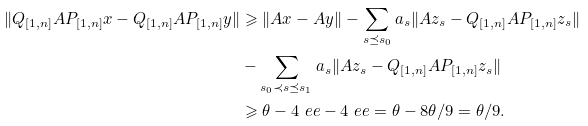<formula> <loc_0><loc_0><loc_500><loc_500>\| Q _ { [ 1 , n ] } A P _ { [ 1 , n ] } x - Q _ { [ 1 , n ] } A P _ { [ 1 , n ] } y \| & \geqslant \| A x - A y \| - \sum _ { s \preceq s _ { 0 } } a _ { s } \| A z _ { s } - Q _ { [ 1 , n ] } A P _ { [ 1 , n ] } z _ { s } \| \\ & - \sum _ { s _ { 0 } \prec s \preceq s _ { 1 } } a _ { s } \| A z _ { s } - Q _ { [ 1 , n ] } A P _ { [ 1 , n ] } z _ { s } \| \\ & \geqslant \theta - 4 \ e e - 4 \ e e = \theta - 8 \theta / 9 = \theta / 9 .</formula> 